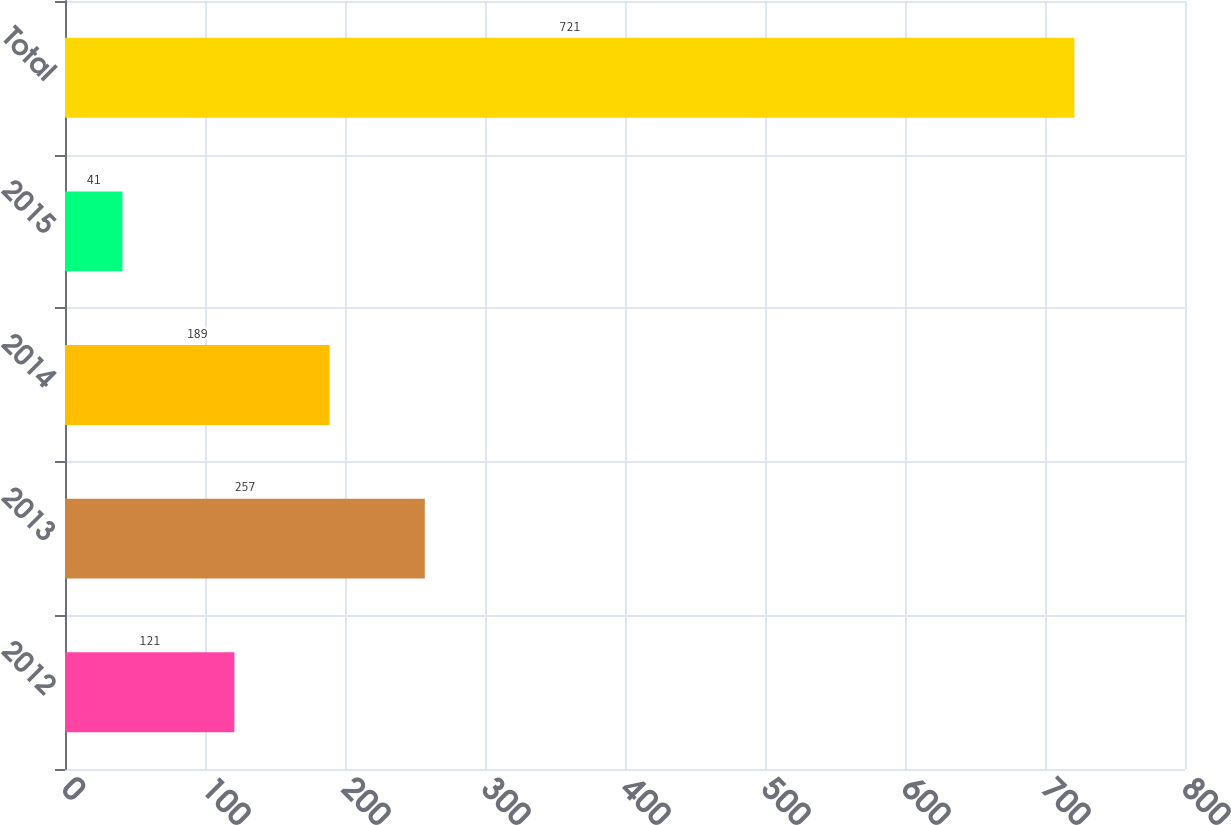<chart> <loc_0><loc_0><loc_500><loc_500><bar_chart><fcel>2012<fcel>2013<fcel>2014<fcel>2015<fcel>Total<nl><fcel>121<fcel>257<fcel>189<fcel>41<fcel>721<nl></chart> 